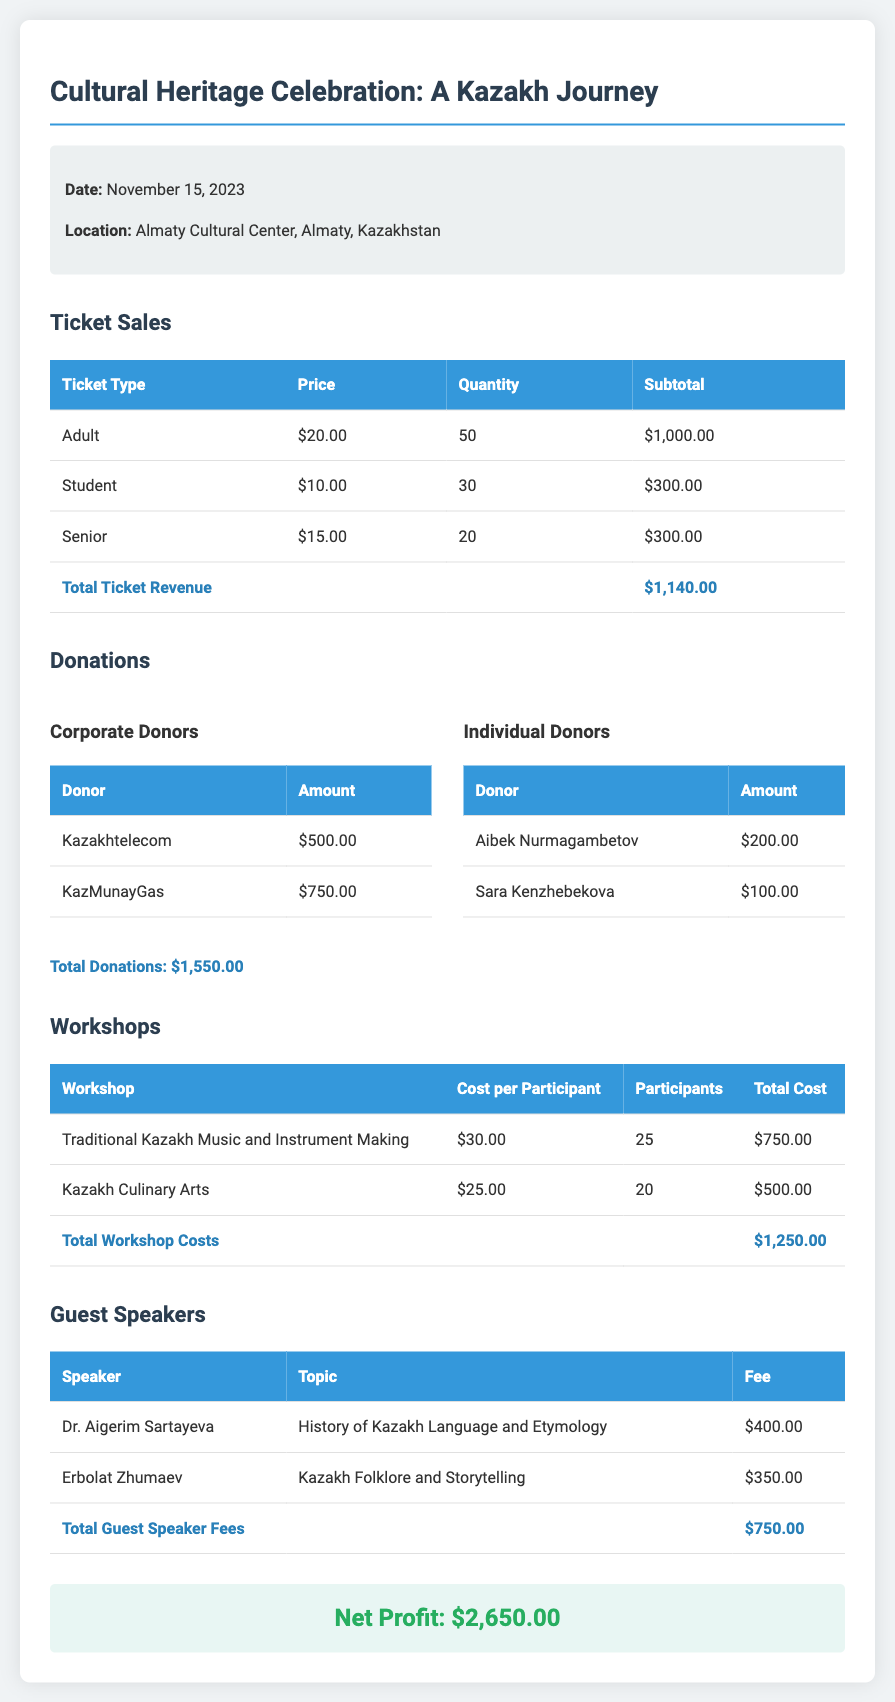what is the date of the event? The date of the event is mentioned in the event details section of the document as November 15, 2023.
Answer: November 15, 2023 what is the total ticket revenue? The total ticket revenue is calculated from the subtotals of each ticket type, resulting in $1,140.00.
Answer: $1,140.00 who are the corporate donors? The corporate donors listed in the donations section are Kazakhtelecom and KazMunayGas.
Answer: Kazakhtelecom, KazMunayGas how many students purchased tickets? The document specifies that 30 student tickets were purchased in the ticket sales section.
Answer: 30 what is the total cost for workshops? The total cost for workshops is the sum of each workshop's total, which amounts to $1,250.00.
Answer: $1,250.00 who is the guest speaker discussing the history of Kazakh language? The guest speaker for that topic is Dr. Aigerim Sartayeva, as listed in the guest speakers section.
Answer: Dr. Aigerim Sartayeva what is the total donations amount? The total donations sum from both corporate and individual donors is stated as $1,550.00 in the donations section.
Answer: $1,550.00 what is the net profit from the event? The net profit is calculated and displayed at the end of the document, which is $2,650.00.
Answer: $2,650.00 